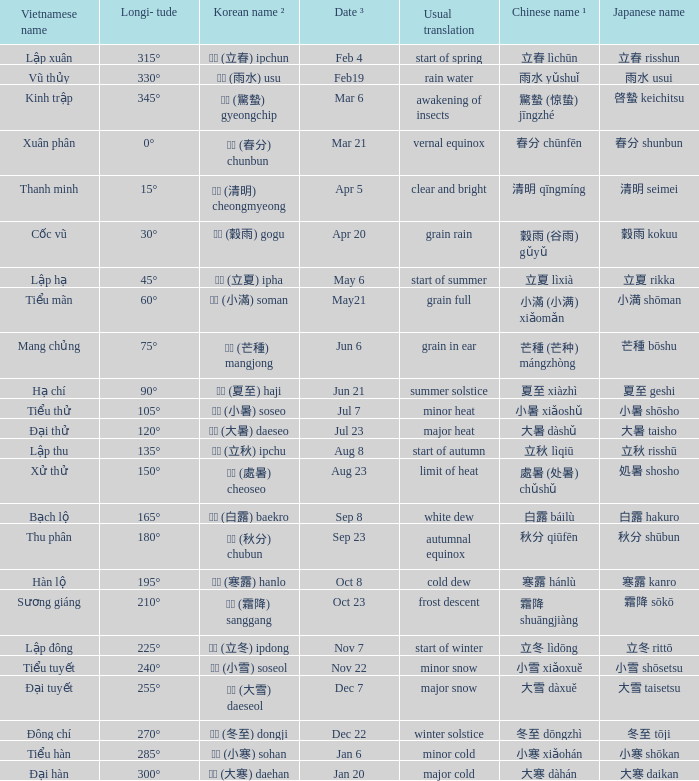WHich Usual translation is on sep 23? Autumnal equinox. 